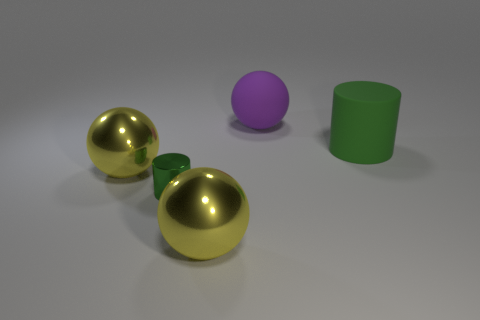There is a big thing that is the same material as the large green cylinder; what shape is it?
Your response must be concise. Sphere. Do the big yellow thing that is in front of the green shiny cylinder and the purple matte object have the same shape?
Your response must be concise. Yes. There is a object that is behind the large green cylinder that is behind the tiny object; what size is it?
Provide a succinct answer. Large. The big object that is the same material as the big green cylinder is what color?
Provide a succinct answer. Purple. How many spheres are the same size as the green rubber object?
Provide a short and direct response. 3. How many green things are metal objects or large matte things?
Keep it short and to the point. 2. What number of objects are tiny cyan metal cylinders or green objects to the left of the big green rubber thing?
Provide a succinct answer. 1. What is the cylinder left of the purple rubber thing made of?
Your answer should be compact. Metal. There is a purple matte thing that is the same size as the green rubber thing; what is its shape?
Your answer should be compact. Sphere. Is there a large blue metal thing of the same shape as the green rubber object?
Offer a very short reply. No. 